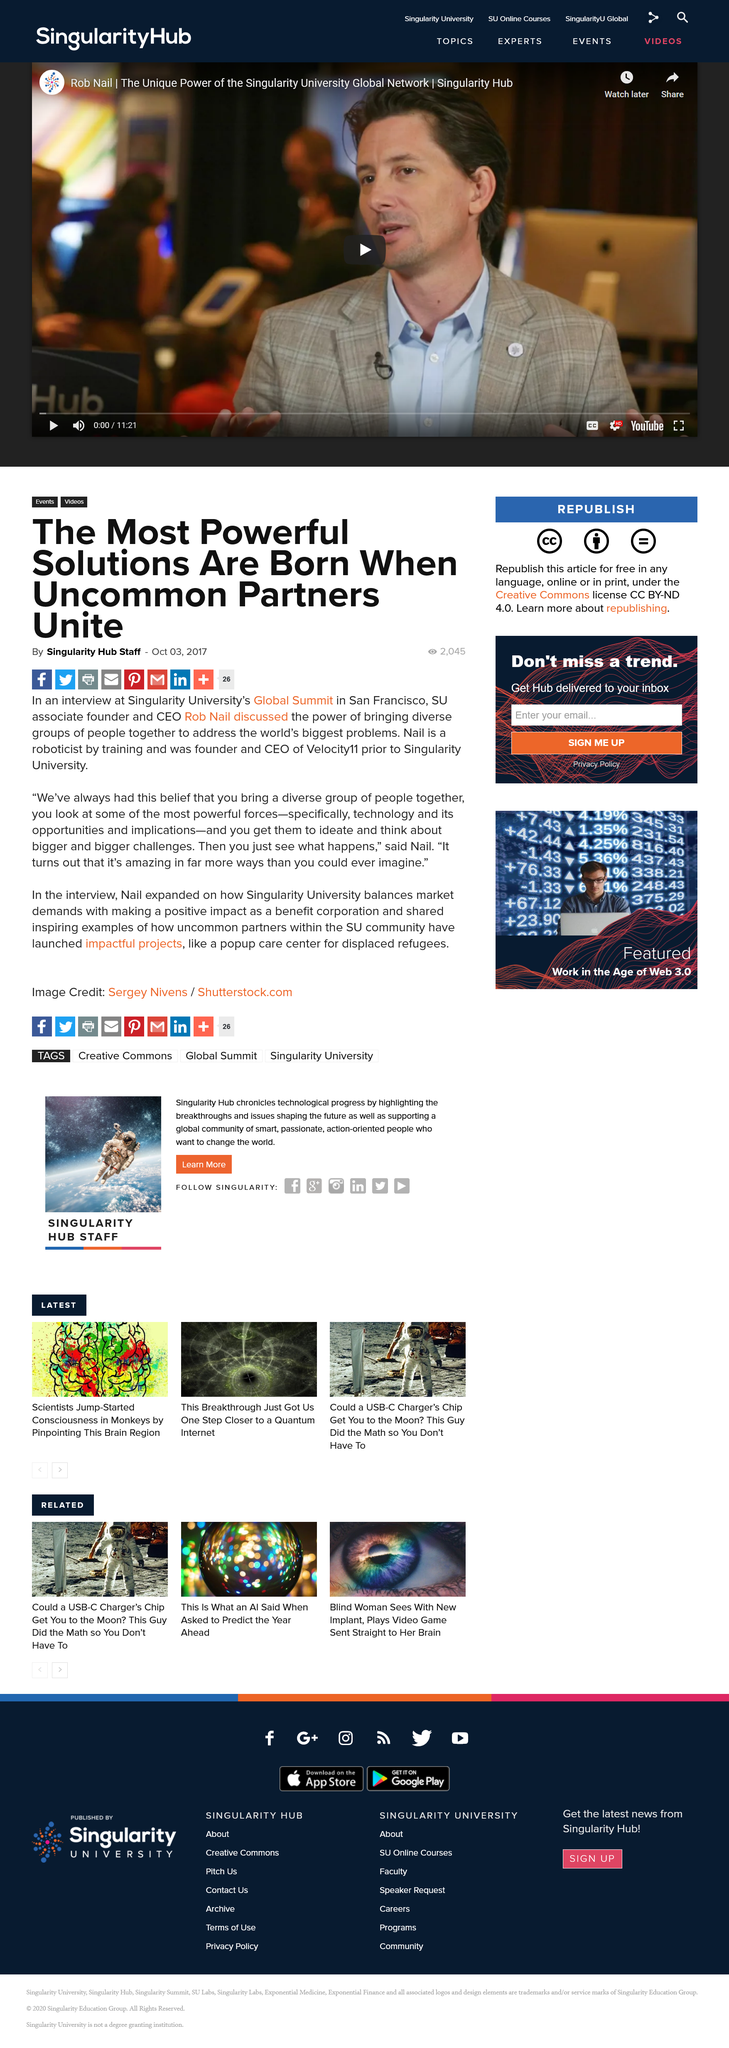Highlight a few significant elements in this photo. The most powerful solutions are born when uncommon partners unite, and they are brought to life at the moment of conception. Nail is a roboticist by training and was the founder and CEO of Velocity11 prior to Singularity University. At the Singularity University's Global Summit in San Francisco, Rob Nail discussed the power of bringing diverse groups of people together to address the world's biggest problems. 